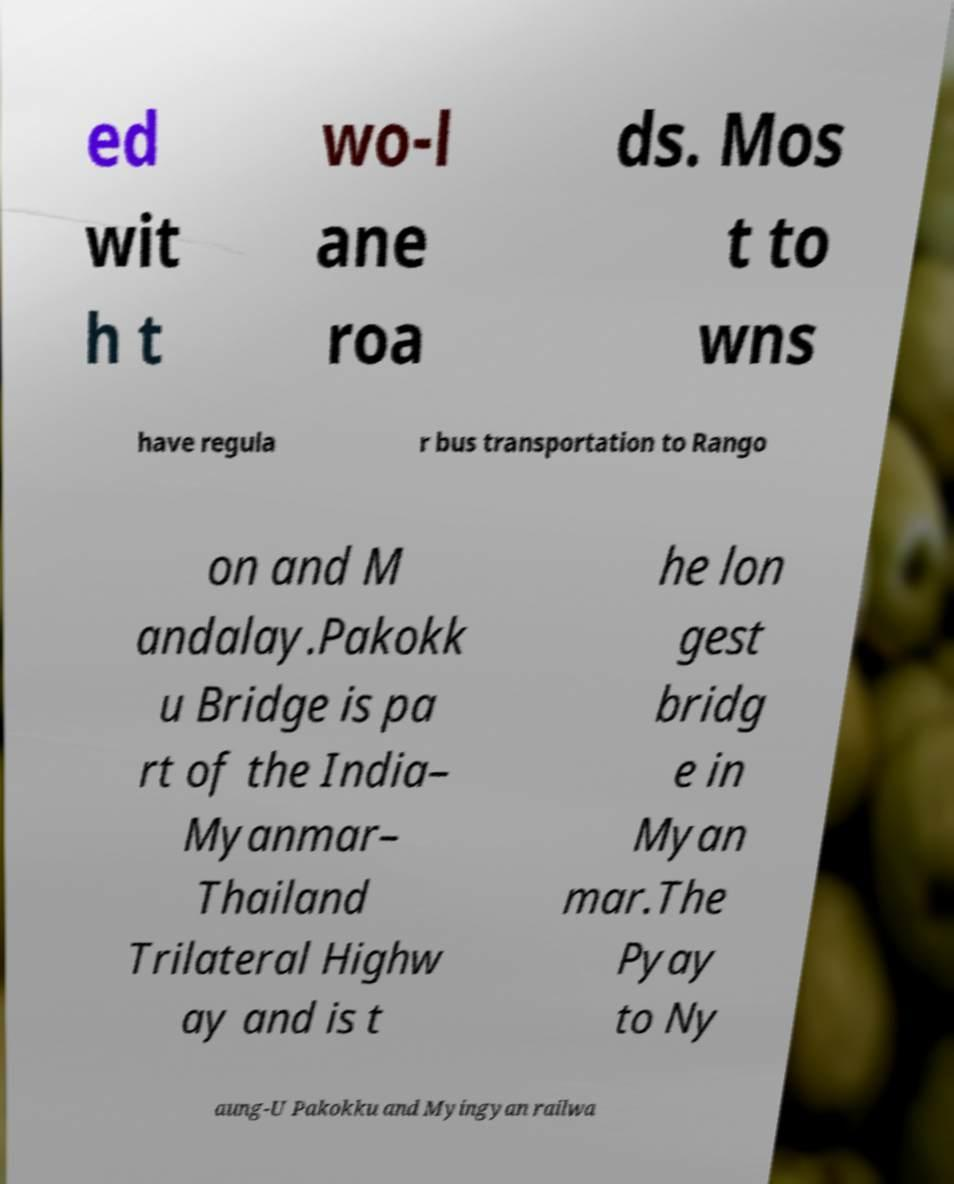Can you read and provide the text displayed in the image?This photo seems to have some interesting text. Can you extract and type it out for me? ed wit h t wo-l ane roa ds. Mos t to wns have regula r bus transportation to Rango on and M andalay.Pakokk u Bridge is pa rt of the India– Myanmar– Thailand Trilateral Highw ay and is t he lon gest bridg e in Myan mar.The Pyay to Ny aung-U Pakokku and Myingyan railwa 